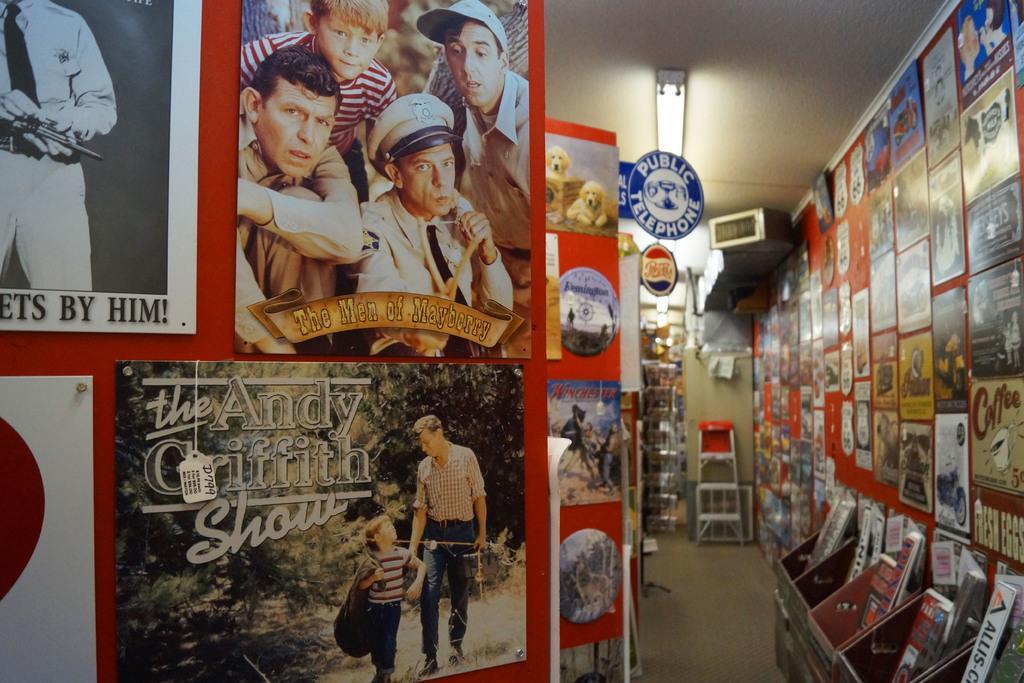Describe this image in one or two sentences. Inside a store there are a lot of posters attached to the wall and in front of one of the wall there are collection of books. 